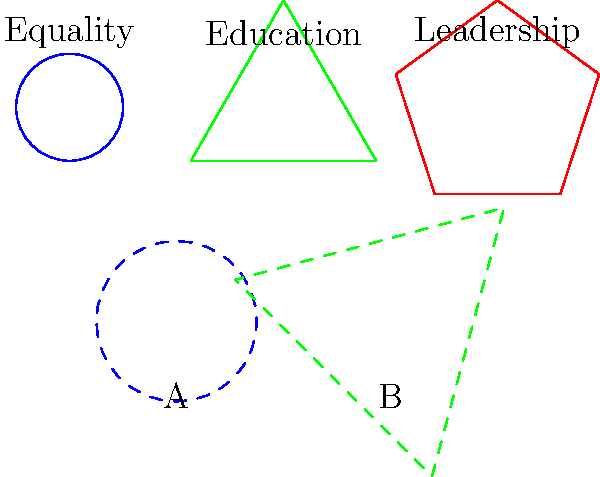In the diagram above, three shapes represent different aspects of women's empowerment: a circle for equality, a triangle for education, and a pentagon for leadership. Shape A is derived from the circle, and Shape B is derived from the triangle. Determine the composite transformation that would transform the original triangle (education) into Shape B. To determine the composite transformation, we need to analyze the changes applied to the original triangle:

1. Scale: The size of Shape B is larger than the original triangle. We can estimate that it has been scaled by a factor of 1.5.

2. Rotation: Shape B appears to be rotated clockwise. The rotation seems to be approximately -45 degrees (or 315 degrees counterclockwise).

3. Translation: The center of Shape B has been moved from its original position (0,1) to approximately (1,-1).

The composite transformation can be described as a sequence of these three transformations:

1. Scale by a factor of 1.5
2. Rotate by -45 degrees
3. Translate by the vector $\langle 1, -2 \rangle$

In mathematical notation, if we denote scaling by $S$, rotation by $R$, and translation by $T$, the composite transformation $C$ can be expressed as:

$$ C = T \circ R \circ S $$

Where:
$S$ : Scale by 1.5
$R$ : Rotate by -45°
$T$ : Translate by $\langle 1, -2 \rangle$

This composite transformation, when applied to the original triangle, will result in Shape B.
Answer: Scale(1.5) → Rotate(-45°) → Translate$\langle 1, -2 \rangle$ 